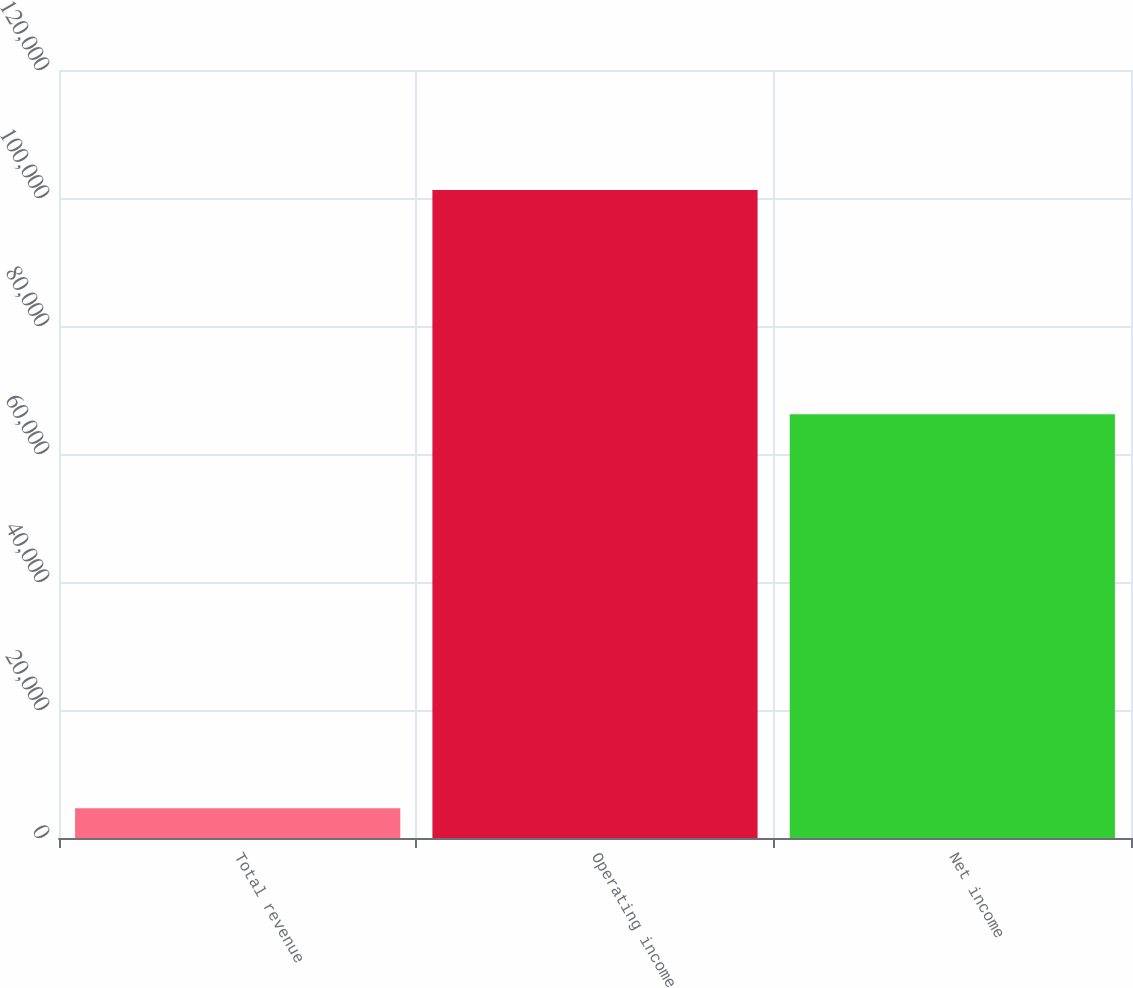Convert chart. <chart><loc_0><loc_0><loc_500><loc_500><bar_chart><fcel>Total revenue<fcel>Operating income<fcel>Net income<nl><fcel>4632<fcel>101232<fcel>66197<nl></chart> 